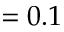<formula> <loc_0><loc_0><loc_500><loc_500>= 0 . 1</formula> 